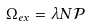Convert formula to latex. <formula><loc_0><loc_0><loc_500><loc_500>\Omega _ { e x } = \lambda N \mathcal { P }</formula> 